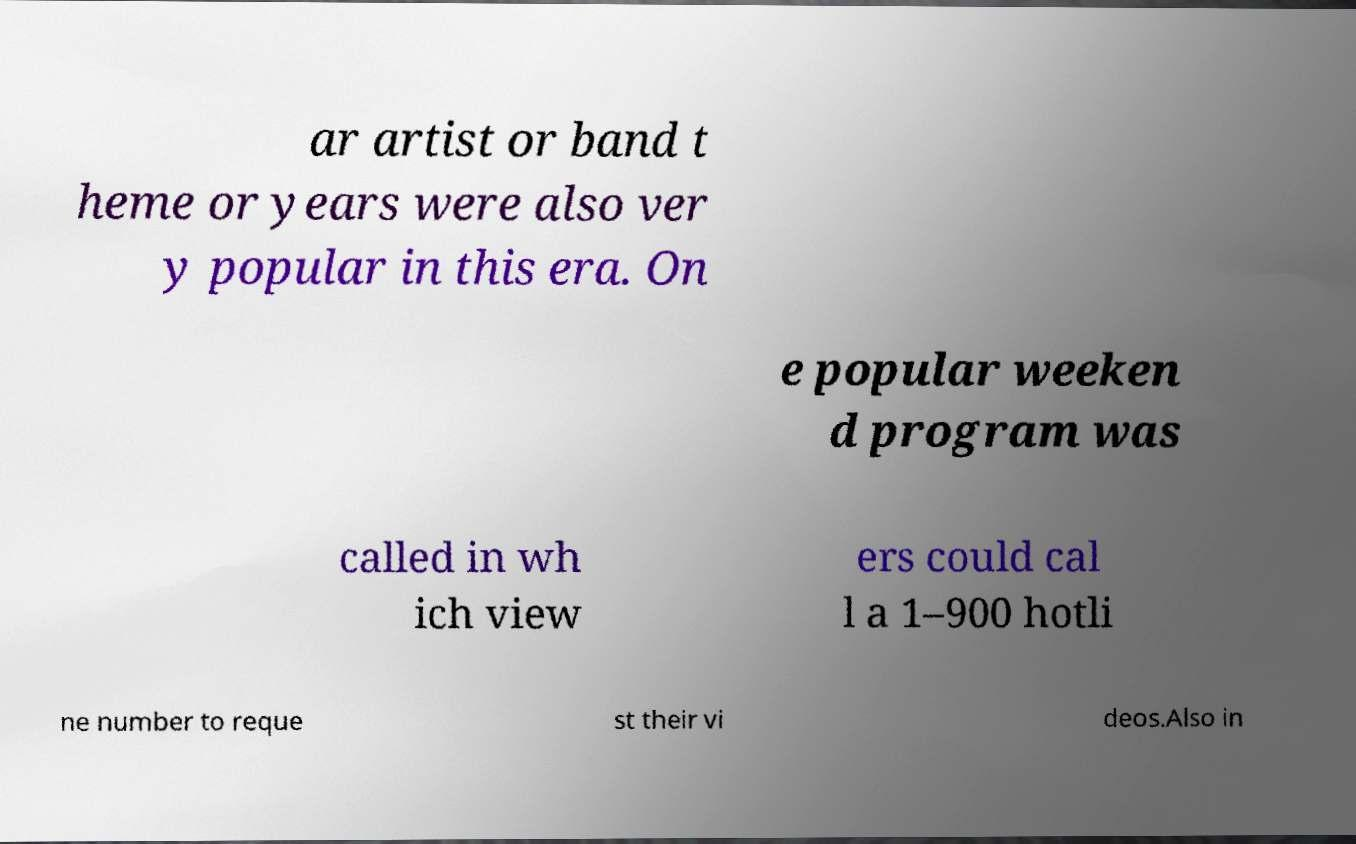Can you accurately transcribe the text from the provided image for me? ar artist or band t heme or years were also ver y popular in this era. On e popular weeken d program was called in wh ich view ers could cal l a 1–900 hotli ne number to reque st their vi deos.Also in 